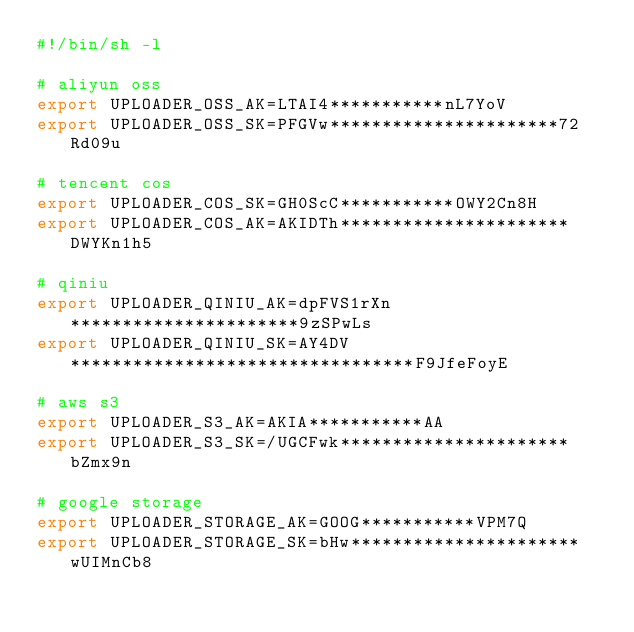<code> <loc_0><loc_0><loc_500><loc_500><_Bash_>#!/bin/sh -l

# aliyun oss
export UPLOADER_OSS_AK=LTAI4***********nL7YoV
export UPLOADER_OSS_SK=PFGVw**********************72Rd09u

# tencent cos
export UPLOADER_COS_SK=GH0ScC***********OWY2Cn8H
export UPLOADER_COS_AK=AKIDTh**********************DWYKn1h5

# qiniu
export UPLOADER_QINIU_AK=dpFVS1rXn**********************9zSPwLs
export UPLOADER_QINIU_SK=AY4DV*********************************F9JfeFoyE

# aws s3
export UPLOADER_S3_AK=AKIA***********AA
export UPLOADER_S3_SK=/UGCFwk**********************bZmx9n

# google storage
export UPLOADER_STORAGE_AK=GOOG***********VPM7Q
export UPLOADER_STORAGE_SK=bHw**********************wUIMnCb8</code> 